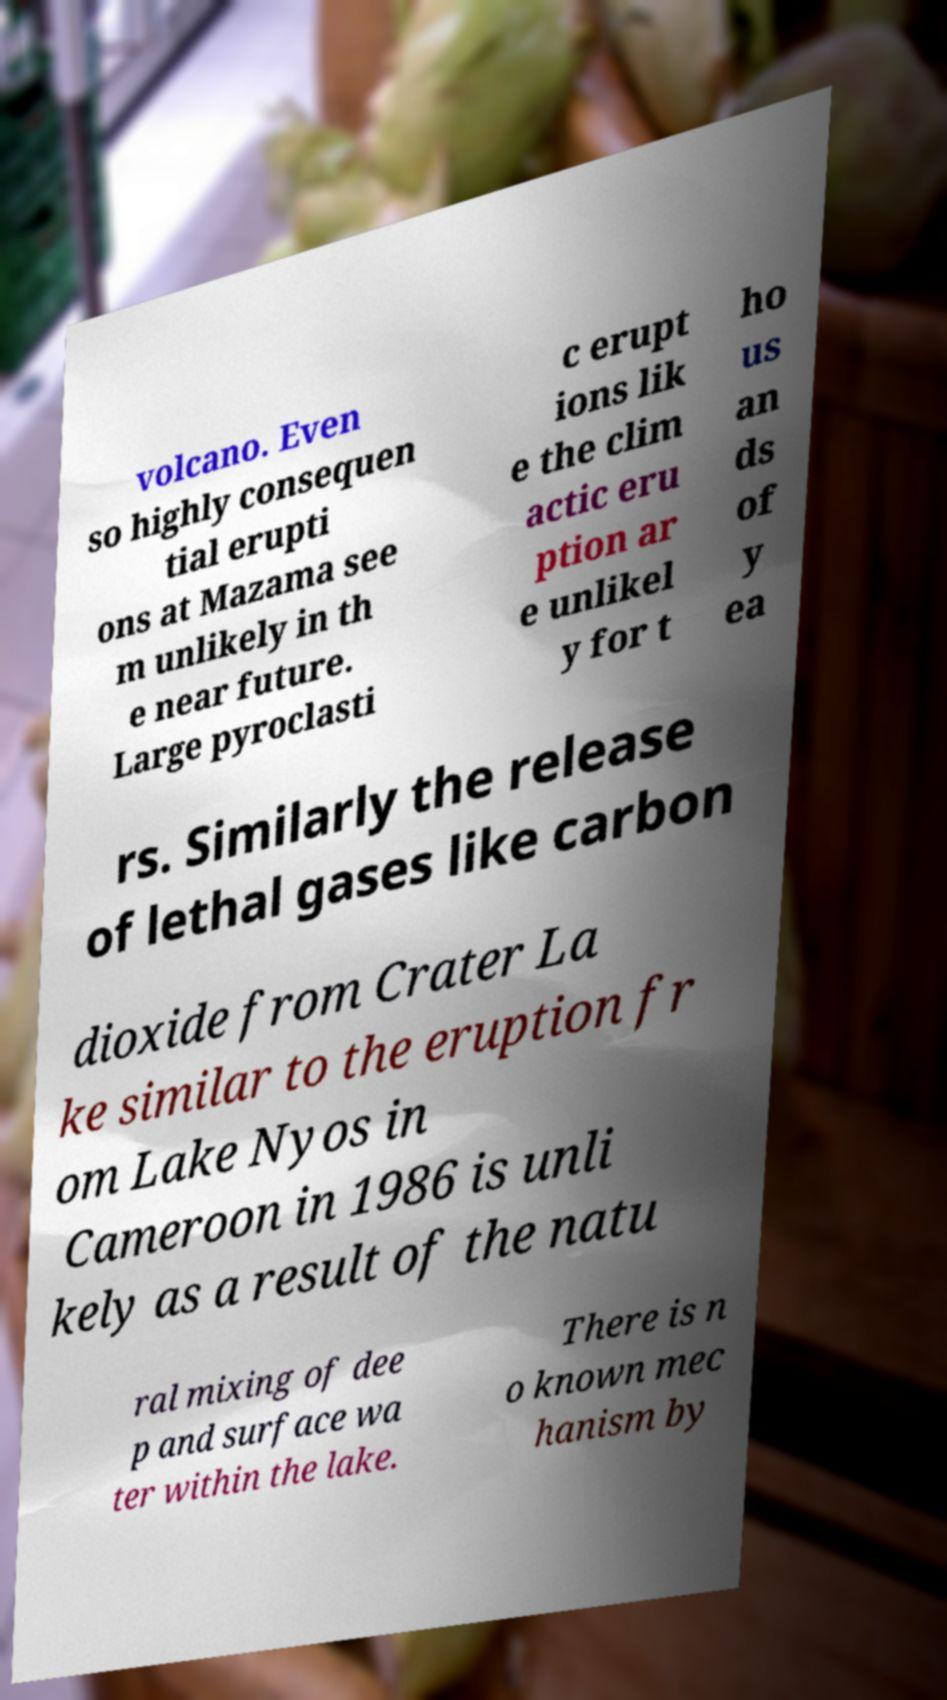I need the written content from this picture converted into text. Can you do that? volcano. Even so highly consequen tial erupti ons at Mazama see m unlikely in th e near future. Large pyroclasti c erupt ions lik e the clim actic eru ption ar e unlikel y for t ho us an ds of y ea rs. Similarly the release of lethal gases like carbon dioxide from Crater La ke similar to the eruption fr om Lake Nyos in Cameroon in 1986 is unli kely as a result of the natu ral mixing of dee p and surface wa ter within the lake. There is n o known mec hanism by 